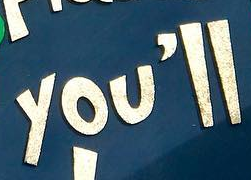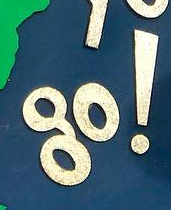Identify the words shown in these images in order, separated by a semicolon. you'll; go! 